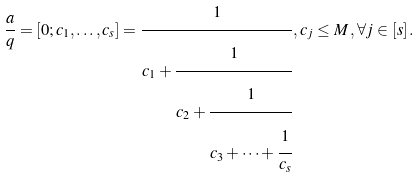Convert formula to latex. <formula><loc_0><loc_0><loc_500><loc_500>\frac { a } { q } = [ 0 ; c _ { 1 } , \dots , c _ { s } ] = \cfrac { 1 } { c _ { 1 } + \cfrac { 1 } { c _ { 2 } + \cfrac { 1 } { c _ { 3 } + \cdots + \cfrac { 1 } { c _ { s } } } } } \, , c _ { j } \leq M \, , \forall j \in [ s ] \, .</formula> 